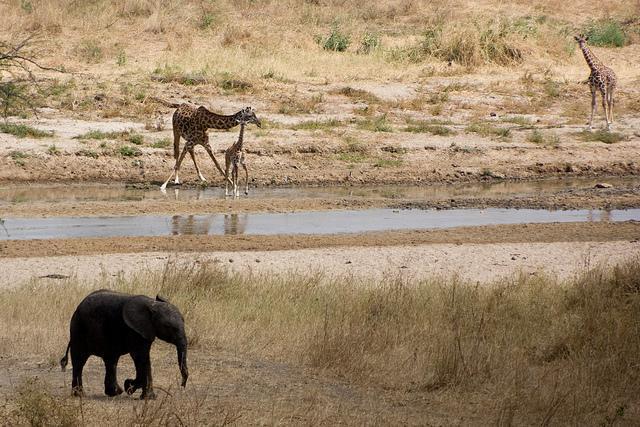How many animals are there?
Give a very brief answer. 4. How many giraffes are in the picture?
Give a very brief answer. 1. How many people are wearing hats?
Give a very brief answer. 0. 